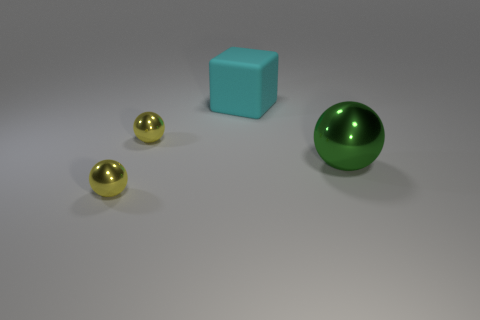What number of objects are either green things or rubber blocks? 2 